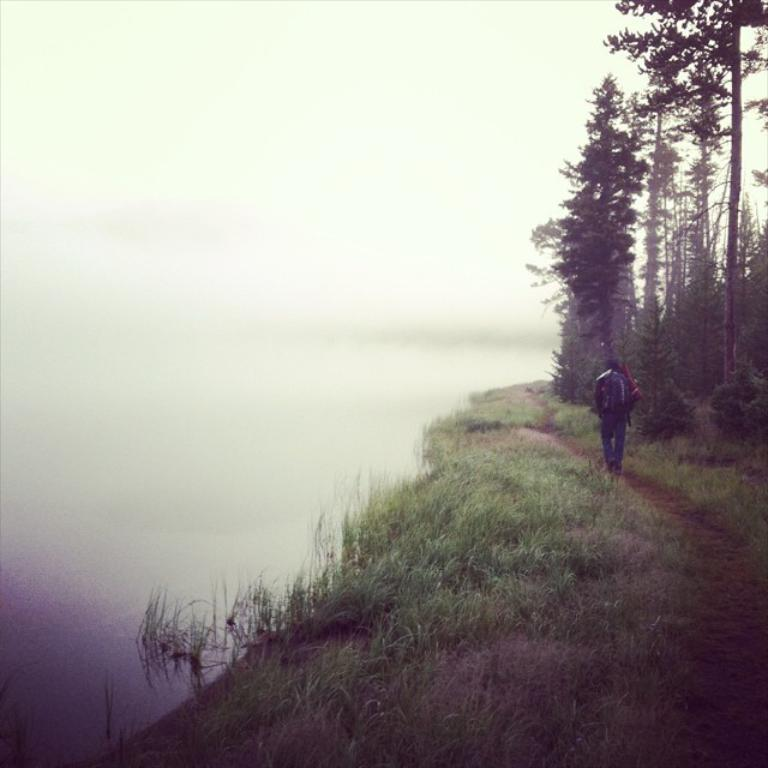What is the person in the image doing? The person in the image is walking. On what surface is the person walking? The person is walking on the grass. What can be seen on the right side of the image? There are trees on the right side of the image. What type of powder is being used by the person walking in the image? There is no powder present in the image, and the person walking is not using any powder. 